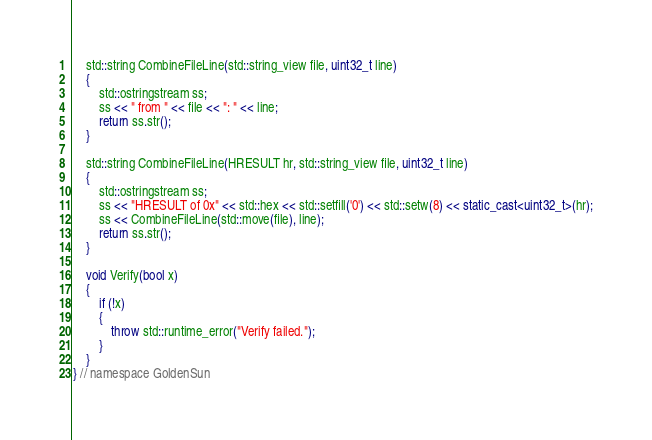Convert code to text. <code><loc_0><loc_0><loc_500><loc_500><_C++_>    std::string CombineFileLine(std::string_view file, uint32_t line)
    {
        std::ostringstream ss;
        ss << " from " << file << ": " << line;
        return ss.str();
    }

    std::string CombineFileLine(HRESULT hr, std::string_view file, uint32_t line)
    {
        std::ostringstream ss;
        ss << "HRESULT of 0x" << std::hex << std::setfill('0') << std::setw(8) << static_cast<uint32_t>(hr);
        ss << CombineFileLine(std::move(file), line);
        return ss.str();
    }

    void Verify(bool x)
    {
        if (!x)
        {
            throw std::runtime_error("Verify failed.");
        }
    }
} // namespace GoldenSun
</code> 